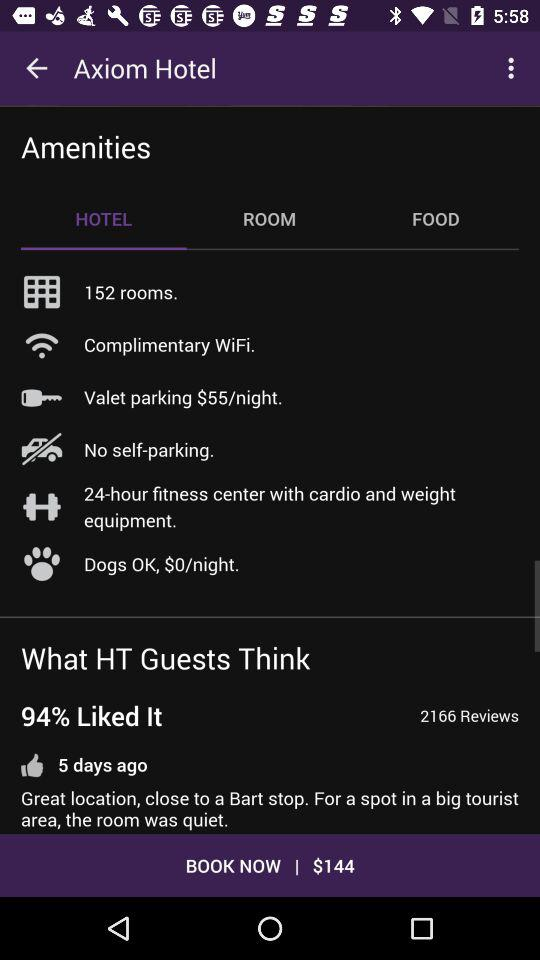What is the per night charge for valet parking? The per-night charge is $55. 